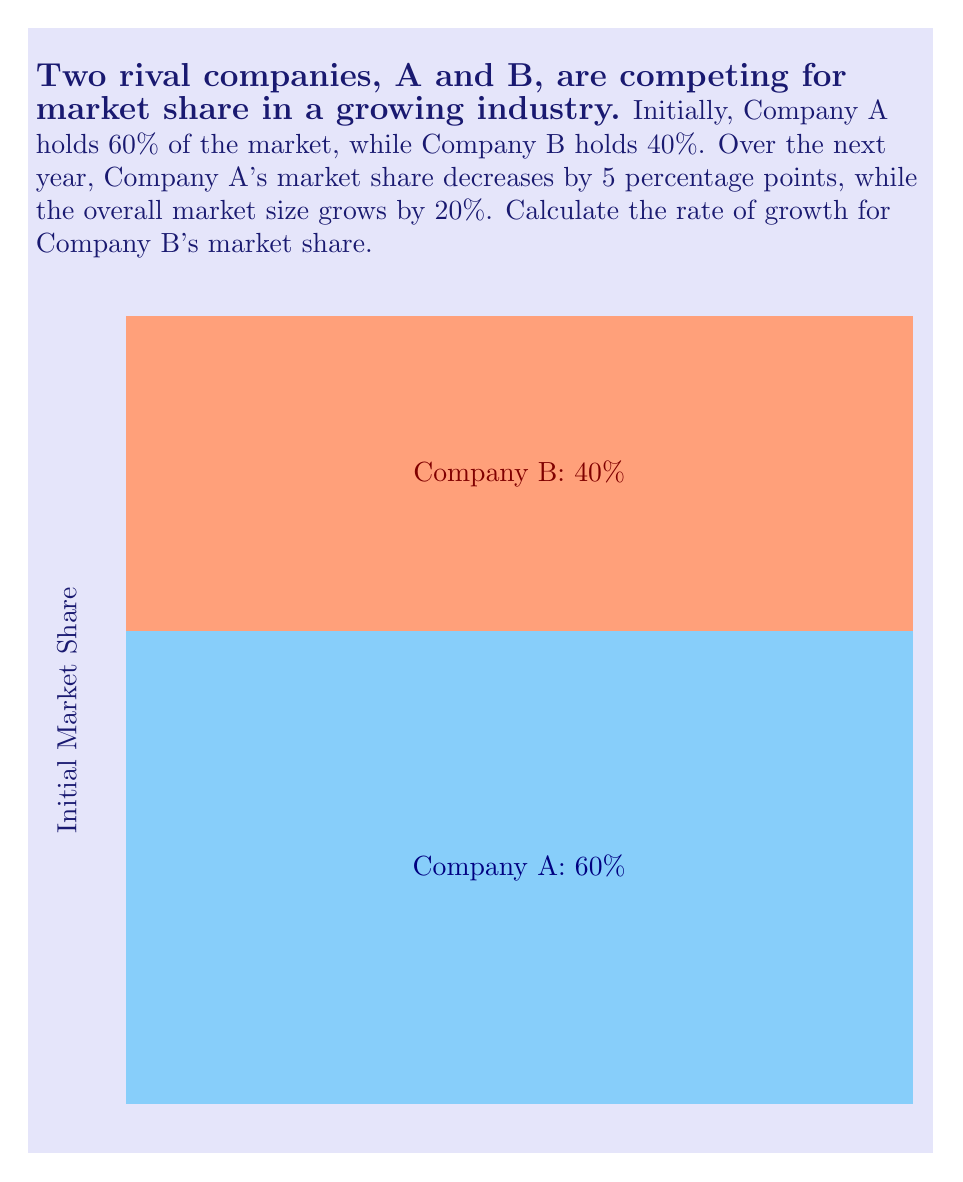Show me your answer to this math problem. Let's approach this step-by-step:

1) Initially:
   Company A: 60% market share
   Company B: 40% market share

2) After one year:
   Company A loses 5 percentage points: 60% - 5% = 55%
   Company B must now have: 100% - 55% = 45% of the new market

3) The overall market has grown by 20%. Let's set the initial market size to 100 units for simplicity:
   New market size = 100 * (1 + 20%) = 100 * 1.2 = 120 units

4) Let's calculate Company B's initial and final market share in absolute terms:
   Initial: 40% of 100 units = 40 units
   Final: 45% of 120 units = 54 units

5) Now we can calculate the growth rate for Company B:
   Growth rate = $\frac{\text{Change in value}}{\text{Original value}} * 100\%$
   
   $= \frac{54 - 40}{40} * 100\% = \frac{14}{40} * 100\% = 35\%$

Therefore, Company B's market share has grown by 35%.
Answer: 35% 